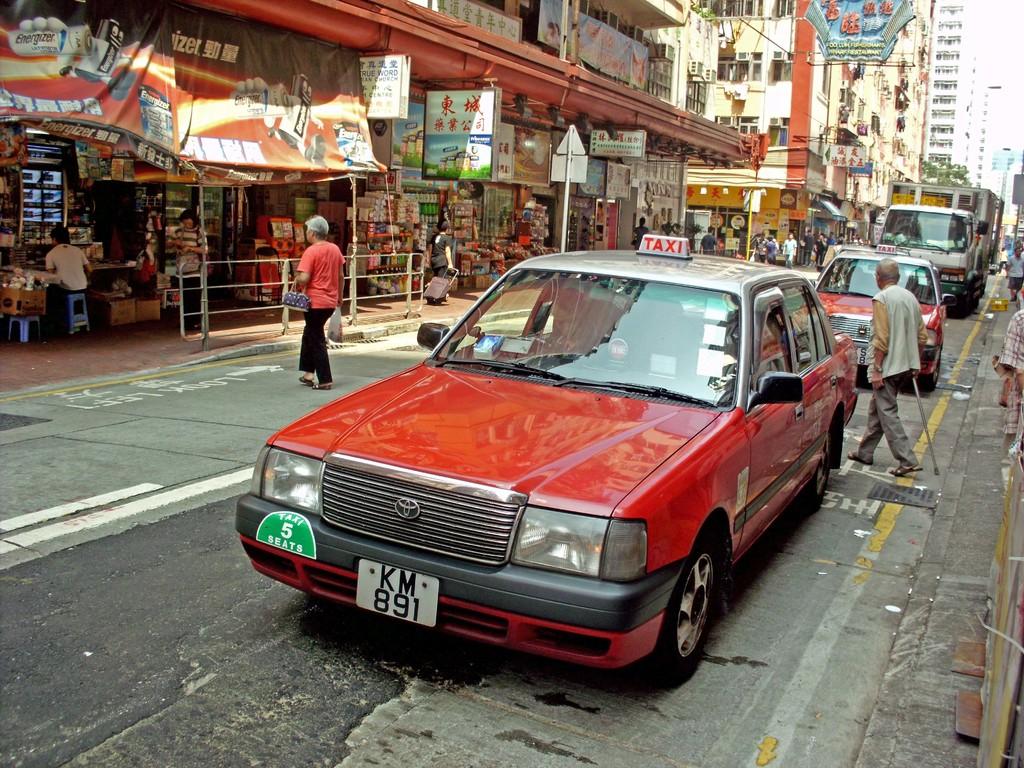What is the plate number for the car?
Provide a short and direct response. Km 891. What service does this offer?
Your answer should be very brief. Taxi. 